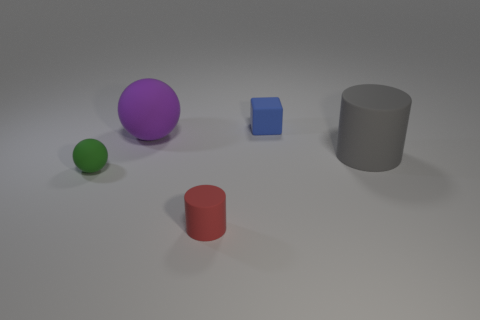What material is the small thing that is on the left side of the tiny cube and right of the big purple thing?
Provide a short and direct response. Rubber. Is there a green rubber ball that is in front of the rubber sphere in front of the matte cylinder that is behind the small green thing?
Make the answer very short. No. Is there any other thing that has the same material as the large gray cylinder?
Provide a short and direct response. Yes. What is the shape of the gray object that is the same material as the red object?
Your response must be concise. Cylinder. Is the number of purple matte objects that are on the right side of the big gray cylinder less than the number of green objects right of the red matte cylinder?
Provide a succinct answer. No. What number of big things are yellow metal balls or purple matte things?
Ensure brevity in your answer.  1. There is a large rubber thing to the left of the large gray object; is its shape the same as the matte thing right of the small cube?
Your answer should be compact. No. How big is the rubber cylinder behind the cylinder that is to the left of the large matte object that is right of the tiny red rubber thing?
Provide a succinct answer. Large. There is a matte ball that is in front of the gray cylinder; what size is it?
Offer a terse response. Small. There is a tiny object that is to the left of the red matte cylinder; what material is it?
Your answer should be very brief. Rubber. 